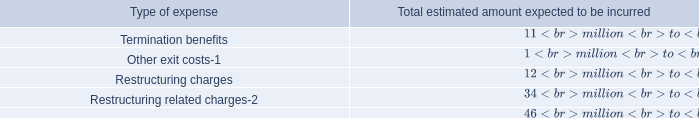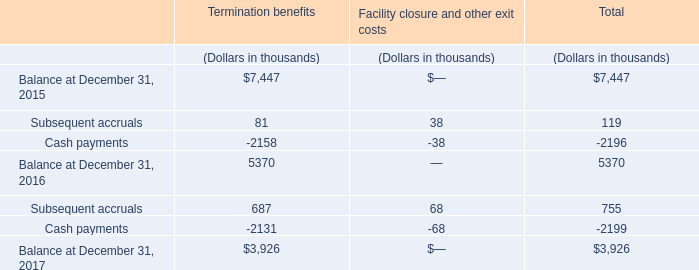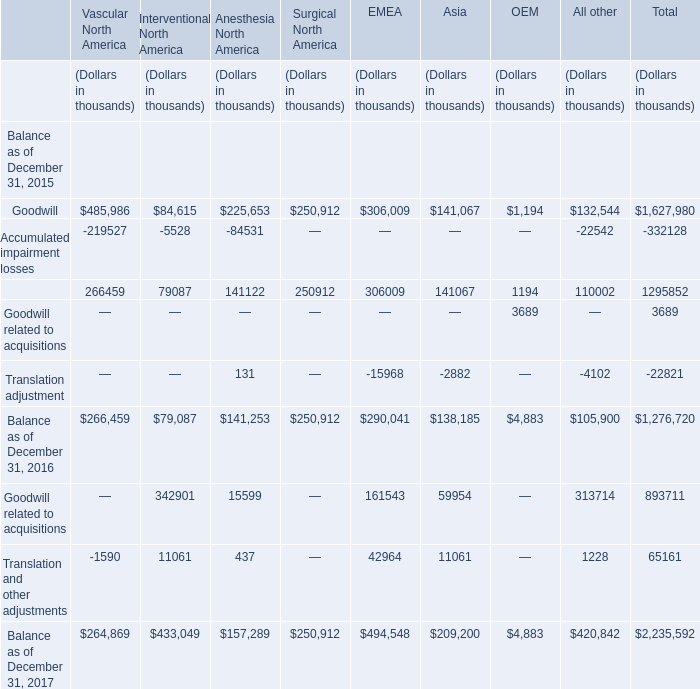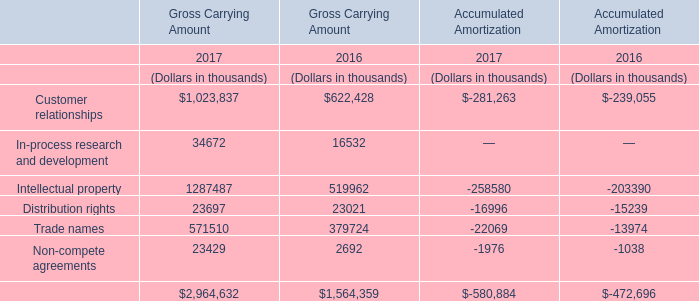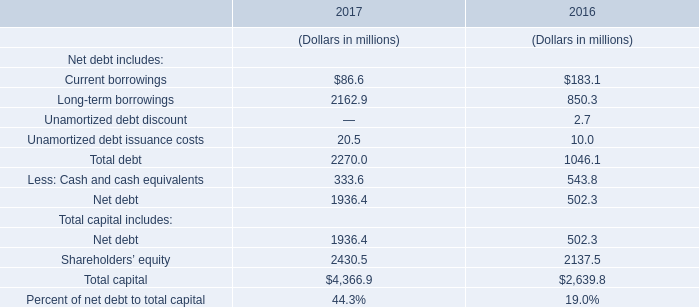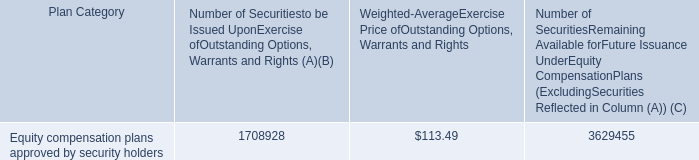Which year is the Gross Carrying Amount for Intellectual property the highest? 
Answer: 2017. 